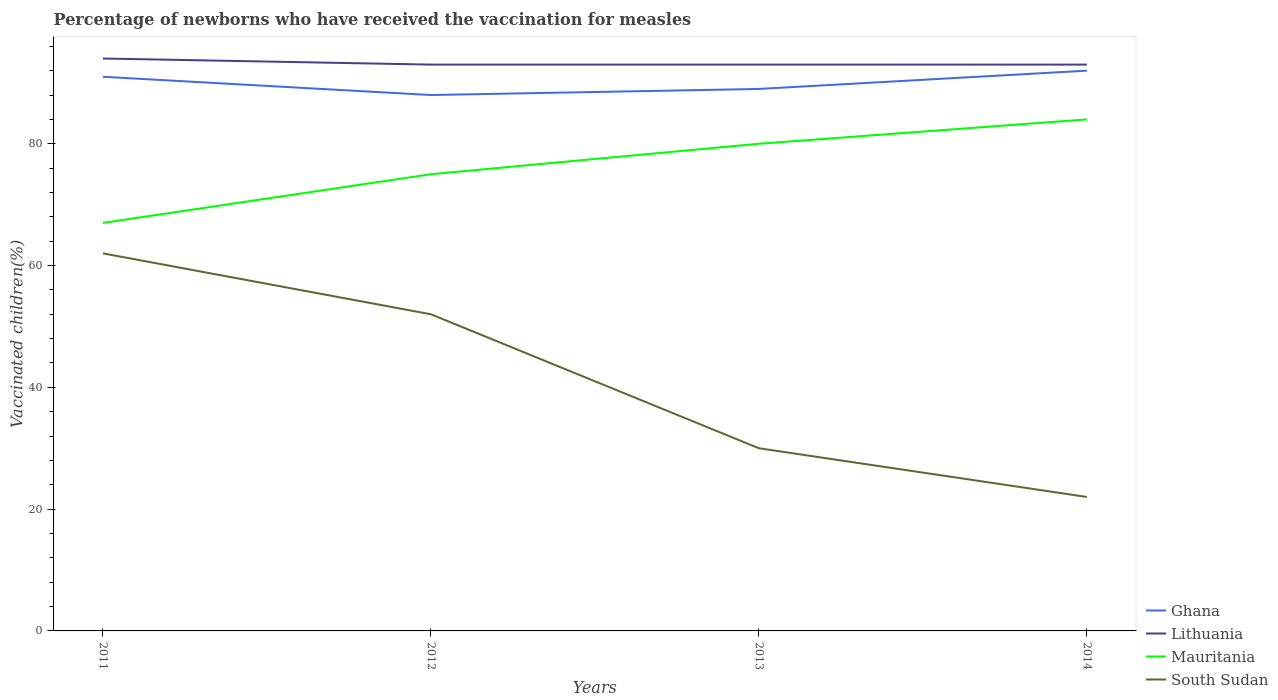How many different coloured lines are there?
Ensure brevity in your answer.  4. Is the number of lines equal to the number of legend labels?
Your response must be concise. Yes. In which year was the percentage of vaccinated children in Ghana maximum?
Make the answer very short. 2012. What is the difference between the highest and the second highest percentage of vaccinated children in Lithuania?
Offer a terse response. 1. Is the percentage of vaccinated children in Ghana strictly greater than the percentage of vaccinated children in Mauritania over the years?
Provide a short and direct response. No. How many lines are there?
Your answer should be compact. 4. How many years are there in the graph?
Your answer should be compact. 4. What is the difference between two consecutive major ticks on the Y-axis?
Keep it short and to the point. 20. Does the graph contain any zero values?
Your response must be concise. No. Where does the legend appear in the graph?
Offer a very short reply. Bottom right. How many legend labels are there?
Keep it short and to the point. 4. How are the legend labels stacked?
Your answer should be very brief. Vertical. What is the title of the graph?
Give a very brief answer. Percentage of newborns who have received the vaccination for measles. What is the label or title of the X-axis?
Keep it short and to the point. Years. What is the label or title of the Y-axis?
Your answer should be compact. Vaccinated children(%). What is the Vaccinated children(%) in Ghana in 2011?
Your answer should be very brief. 91. What is the Vaccinated children(%) of Lithuania in 2011?
Provide a succinct answer. 94. What is the Vaccinated children(%) of South Sudan in 2011?
Provide a short and direct response. 62. What is the Vaccinated children(%) in Ghana in 2012?
Provide a short and direct response. 88. What is the Vaccinated children(%) of Lithuania in 2012?
Keep it short and to the point. 93. What is the Vaccinated children(%) of Mauritania in 2012?
Offer a very short reply. 75. What is the Vaccinated children(%) in South Sudan in 2012?
Keep it short and to the point. 52. What is the Vaccinated children(%) of Ghana in 2013?
Offer a very short reply. 89. What is the Vaccinated children(%) in Lithuania in 2013?
Give a very brief answer. 93. What is the Vaccinated children(%) of Mauritania in 2013?
Keep it short and to the point. 80. What is the Vaccinated children(%) of South Sudan in 2013?
Offer a terse response. 30. What is the Vaccinated children(%) of Ghana in 2014?
Your answer should be compact. 92. What is the Vaccinated children(%) of Lithuania in 2014?
Give a very brief answer. 93. What is the Vaccinated children(%) in Mauritania in 2014?
Your response must be concise. 84. What is the Vaccinated children(%) in South Sudan in 2014?
Your answer should be very brief. 22. Across all years, what is the maximum Vaccinated children(%) in Ghana?
Your answer should be very brief. 92. Across all years, what is the maximum Vaccinated children(%) in Lithuania?
Offer a very short reply. 94. Across all years, what is the maximum Vaccinated children(%) of South Sudan?
Ensure brevity in your answer.  62. Across all years, what is the minimum Vaccinated children(%) in Lithuania?
Offer a terse response. 93. What is the total Vaccinated children(%) in Ghana in the graph?
Make the answer very short. 360. What is the total Vaccinated children(%) of Lithuania in the graph?
Offer a terse response. 373. What is the total Vaccinated children(%) of Mauritania in the graph?
Offer a terse response. 306. What is the total Vaccinated children(%) in South Sudan in the graph?
Keep it short and to the point. 166. What is the difference between the Vaccinated children(%) of Lithuania in 2011 and that in 2013?
Provide a short and direct response. 1. What is the difference between the Vaccinated children(%) of South Sudan in 2011 and that in 2013?
Ensure brevity in your answer.  32. What is the difference between the Vaccinated children(%) in Ghana in 2011 and that in 2014?
Offer a very short reply. -1. What is the difference between the Vaccinated children(%) in Mauritania in 2011 and that in 2014?
Give a very brief answer. -17. What is the difference between the Vaccinated children(%) in Ghana in 2012 and that in 2013?
Offer a very short reply. -1. What is the difference between the Vaccinated children(%) in Mauritania in 2012 and that in 2013?
Offer a terse response. -5. What is the difference between the Vaccinated children(%) in South Sudan in 2012 and that in 2013?
Provide a short and direct response. 22. What is the difference between the Vaccinated children(%) of Lithuania in 2012 and that in 2014?
Keep it short and to the point. 0. What is the difference between the Vaccinated children(%) in South Sudan in 2012 and that in 2014?
Offer a terse response. 30. What is the difference between the Vaccinated children(%) of Ghana in 2013 and that in 2014?
Make the answer very short. -3. What is the difference between the Vaccinated children(%) in Mauritania in 2013 and that in 2014?
Ensure brevity in your answer.  -4. What is the difference between the Vaccinated children(%) in South Sudan in 2013 and that in 2014?
Provide a succinct answer. 8. What is the difference between the Vaccinated children(%) in Ghana in 2011 and the Vaccinated children(%) in Lithuania in 2012?
Provide a succinct answer. -2. What is the difference between the Vaccinated children(%) of Ghana in 2011 and the Vaccinated children(%) of Mauritania in 2012?
Your answer should be very brief. 16. What is the difference between the Vaccinated children(%) in Ghana in 2011 and the Vaccinated children(%) in South Sudan in 2012?
Your answer should be compact. 39. What is the difference between the Vaccinated children(%) in Ghana in 2011 and the Vaccinated children(%) in Mauritania in 2013?
Provide a succinct answer. 11. What is the difference between the Vaccinated children(%) in Lithuania in 2011 and the Vaccinated children(%) in Mauritania in 2013?
Your answer should be compact. 14. What is the difference between the Vaccinated children(%) in Lithuania in 2011 and the Vaccinated children(%) in South Sudan in 2013?
Your answer should be very brief. 64. What is the difference between the Vaccinated children(%) in Mauritania in 2011 and the Vaccinated children(%) in South Sudan in 2013?
Provide a short and direct response. 37. What is the difference between the Vaccinated children(%) of Ghana in 2011 and the Vaccinated children(%) of Lithuania in 2014?
Your answer should be very brief. -2. What is the difference between the Vaccinated children(%) in Ghana in 2011 and the Vaccinated children(%) in Mauritania in 2014?
Offer a terse response. 7. What is the difference between the Vaccinated children(%) of Ghana in 2012 and the Vaccinated children(%) of Mauritania in 2013?
Your answer should be compact. 8. What is the difference between the Vaccinated children(%) in Ghana in 2012 and the Vaccinated children(%) in South Sudan in 2013?
Give a very brief answer. 58. What is the difference between the Vaccinated children(%) in Lithuania in 2012 and the Vaccinated children(%) in Mauritania in 2013?
Ensure brevity in your answer.  13. What is the difference between the Vaccinated children(%) of Mauritania in 2012 and the Vaccinated children(%) of South Sudan in 2013?
Your answer should be compact. 45. What is the difference between the Vaccinated children(%) in Ghana in 2012 and the Vaccinated children(%) in Lithuania in 2014?
Provide a succinct answer. -5. What is the difference between the Vaccinated children(%) in Lithuania in 2012 and the Vaccinated children(%) in South Sudan in 2014?
Keep it short and to the point. 71. What is the difference between the Vaccinated children(%) in Ghana in 2013 and the Vaccinated children(%) in South Sudan in 2014?
Offer a terse response. 67. What is the difference between the Vaccinated children(%) in Lithuania in 2013 and the Vaccinated children(%) in Mauritania in 2014?
Ensure brevity in your answer.  9. What is the difference between the Vaccinated children(%) of Lithuania in 2013 and the Vaccinated children(%) of South Sudan in 2014?
Offer a terse response. 71. What is the difference between the Vaccinated children(%) in Mauritania in 2013 and the Vaccinated children(%) in South Sudan in 2014?
Provide a short and direct response. 58. What is the average Vaccinated children(%) of Ghana per year?
Your response must be concise. 90. What is the average Vaccinated children(%) in Lithuania per year?
Ensure brevity in your answer.  93.25. What is the average Vaccinated children(%) in Mauritania per year?
Offer a very short reply. 76.5. What is the average Vaccinated children(%) in South Sudan per year?
Provide a succinct answer. 41.5. In the year 2011, what is the difference between the Vaccinated children(%) of Ghana and Vaccinated children(%) of South Sudan?
Give a very brief answer. 29. In the year 2011, what is the difference between the Vaccinated children(%) of Lithuania and Vaccinated children(%) of Mauritania?
Offer a terse response. 27. In the year 2011, what is the difference between the Vaccinated children(%) in Lithuania and Vaccinated children(%) in South Sudan?
Offer a terse response. 32. In the year 2013, what is the difference between the Vaccinated children(%) in Ghana and Vaccinated children(%) in Lithuania?
Your answer should be compact. -4. In the year 2013, what is the difference between the Vaccinated children(%) of Ghana and Vaccinated children(%) of Mauritania?
Provide a short and direct response. 9. In the year 2013, what is the difference between the Vaccinated children(%) of Ghana and Vaccinated children(%) of South Sudan?
Your answer should be very brief. 59. In the year 2013, what is the difference between the Vaccinated children(%) in Lithuania and Vaccinated children(%) in Mauritania?
Your answer should be compact. 13. In the year 2014, what is the difference between the Vaccinated children(%) of Lithuania and Vaccinated children(%) of Mauritania?
Offer a terse response. 9. In the year 2014, what is the difference between the Vaccinated children(%) in Lithuania and Vaccinated children(%) in South Sudan?
Your response must be concise. 71. In the year 2014, what is the difference between the Vaccinated children(%) in Mauritania and Vaccinated children(%) in South Sudan?
Ensure brevity in your answer.  62. What is the ratio of the Vaccinated children(%) of Ghana in 2011 to that in 2012?
Offer a very short reply. 1.03. What is the ratio of the Vaccinated children(%) in Lithuania in 2011 to that in 2012?
Ensure brevity in your answer.  1.01. What is the ratio of the Vaccinated children(%) in Mauritania in 2011 to that in 2012?
Keep it short and to the point. 0.89. What is the ratio of the Vaccinated children(%) in South Sudan in 2011 to that in 2012?
Your response must be concise. 1.19. What is the ratio of the Vaccinated children(%) in Ghana in 2011 to that in 2013?
Ensure brevity in your answer.  1.02. What is the ratio of the Vaccinated children(%) of Lithuania in 2011 to that in 2013?
Make the answer very short. 1.01. What is the ratio of the Vaccinated children(%) in Mauritania in 2011 to that in 2013?
Your answer should be very brief. 0.84. What is the ratio of the Vaccinated children(%) in South Sudan in 2011 to that in 2013?
Give a very brief answer. 2.07. What is the ratio of the Vaccinated children(%) of Ghana in 2011 to that in 2014?
Offer a very short reply. 0.99. What is the ratio of the Vaccinated children(%) in Lithuania in 2011 to that in 2014?
Your response must be concise. 1.01. What is the ratio of the Vaccinated children(%) of Mauritania in 2011 to that in 2014?
Ensure brevity in your answer.  0.8. What is the ratio of the Vaccinated children(%) in South Sudan in 2011 to that in 2014?
Keep it short and to the point. 2.82. What is the ratio of the Vaccinated children(%) of Ghana in 2012 to that in 2013?
Make the answer very short. 0.99. What is the ratio of the Vaccinated children(%) of Lithuania in 2012 to that in 2013?
Your response must be concise. 1. What is the ratio of the Vaccinated children(%) in South Sudan in 2012 to that in 2013?
Provide a short and direct response. 1.73. What is the ratio of the Vaccinated children(%) of Ghana in 2012 to that in 2014?
Ensure brevity in your answer.  0.96. What is the ratio of the Vaccinated children(%) of Mauritania in 2012 to that in 2014?
Provide a short and direct response. 0.89. What is the ratio of the Vaccinated children(%) in South Sudan in 2012 to that in 2014?
Offer a terse response. 2.36. What is the ratio of the Vaccinated children(%) of Ghana in 2013 to that in 2014?
Your answer should be very brief. 0.97. What is the ratio of the Vaccinated children(%) in Lithuania in 2013 to that in 2014?
Your answer should be very brief. 1. What is the ratio of the Vaccinated children(%) in South Sudan in 2013 to that in 2014?
Provide a succinct answer. 1.36. What is the difference between the highest and the second highest Vaccinated children(%) of Ghana?
Your answer should be compact. 1. What is the difference between the highest and the second highest Vaccinated children(%) in South Sudan?
Make the answer very short. 10. What is the difference between the highest and the lowest Vaccinated children(%) in Lithuania?
Ensure brevity in your answer.  1. What is the difference between the highest and the lowest Vaccinated children(%) of South Sudan?
Your answer should be compact. 40. 